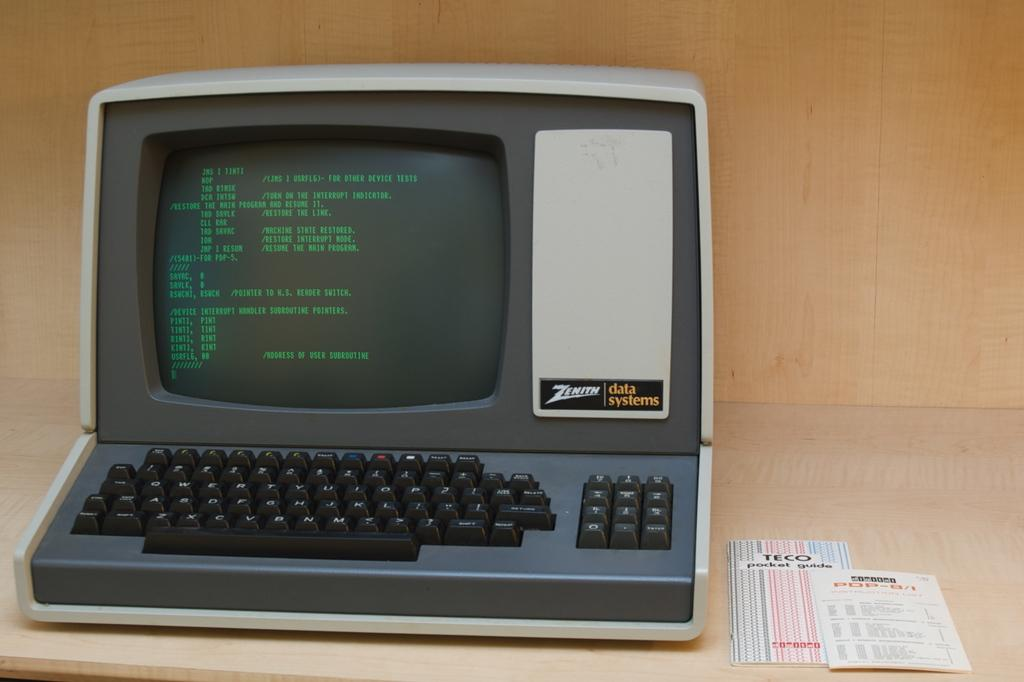<image>
Describe the image concisely. An old Zenith Data Systems computer with a green monitor. 